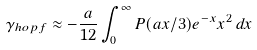<formula> <loc_0><loc_0><loc_500><loc_500>\gamma _ { h o p f } \approx - \frac { a } { 1 2 } \int _ { 0 } ^ { \infty } P ( a x / 3 ) e ^ { - x } x ^ { 2 } \, d x</formula> 